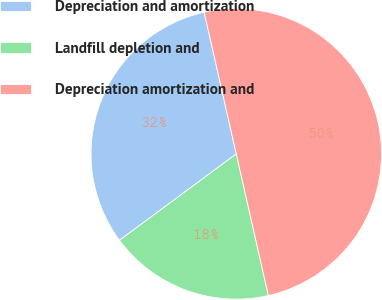Convert chart. <chart><loc_0><loc_0><loc_500><loc_500><pie_chart><fcel>Depreciation and amortization<fcel>Landfill depletion and<fcel>Depreciation amortization and<nl><fcel>31.59%<fcel>18.41%<fcel>50.0%<nl></chart> 